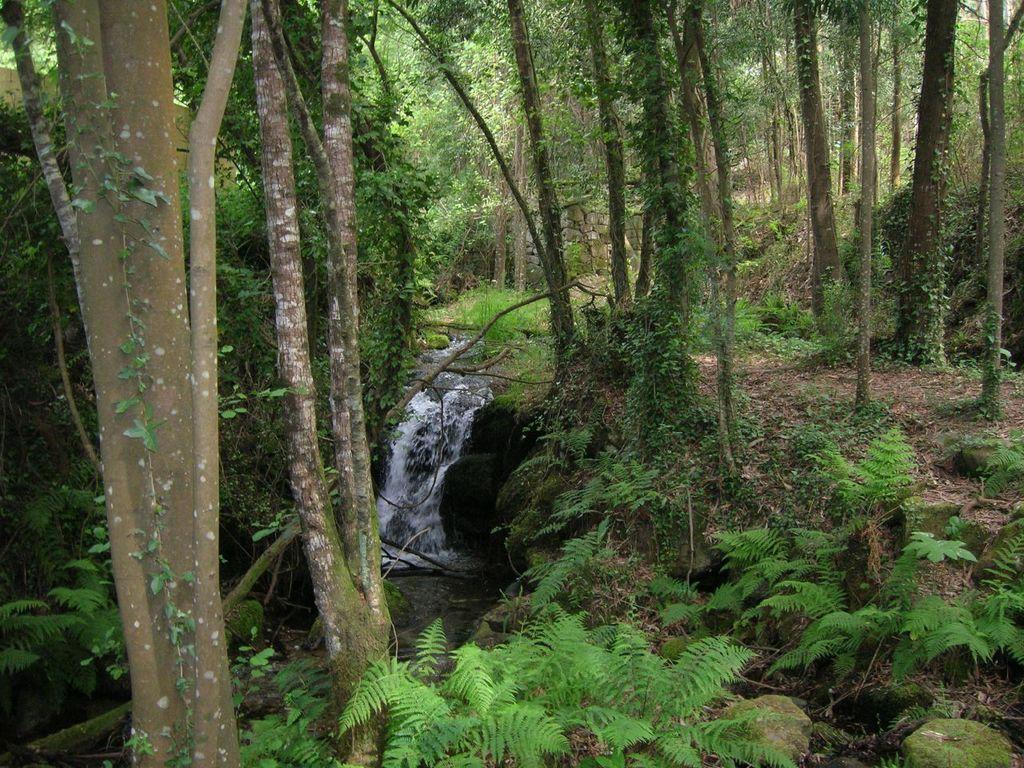Could you give a brief overview of what you see in this image? In this picture I can see the water in the middle, there are trees in this image. 